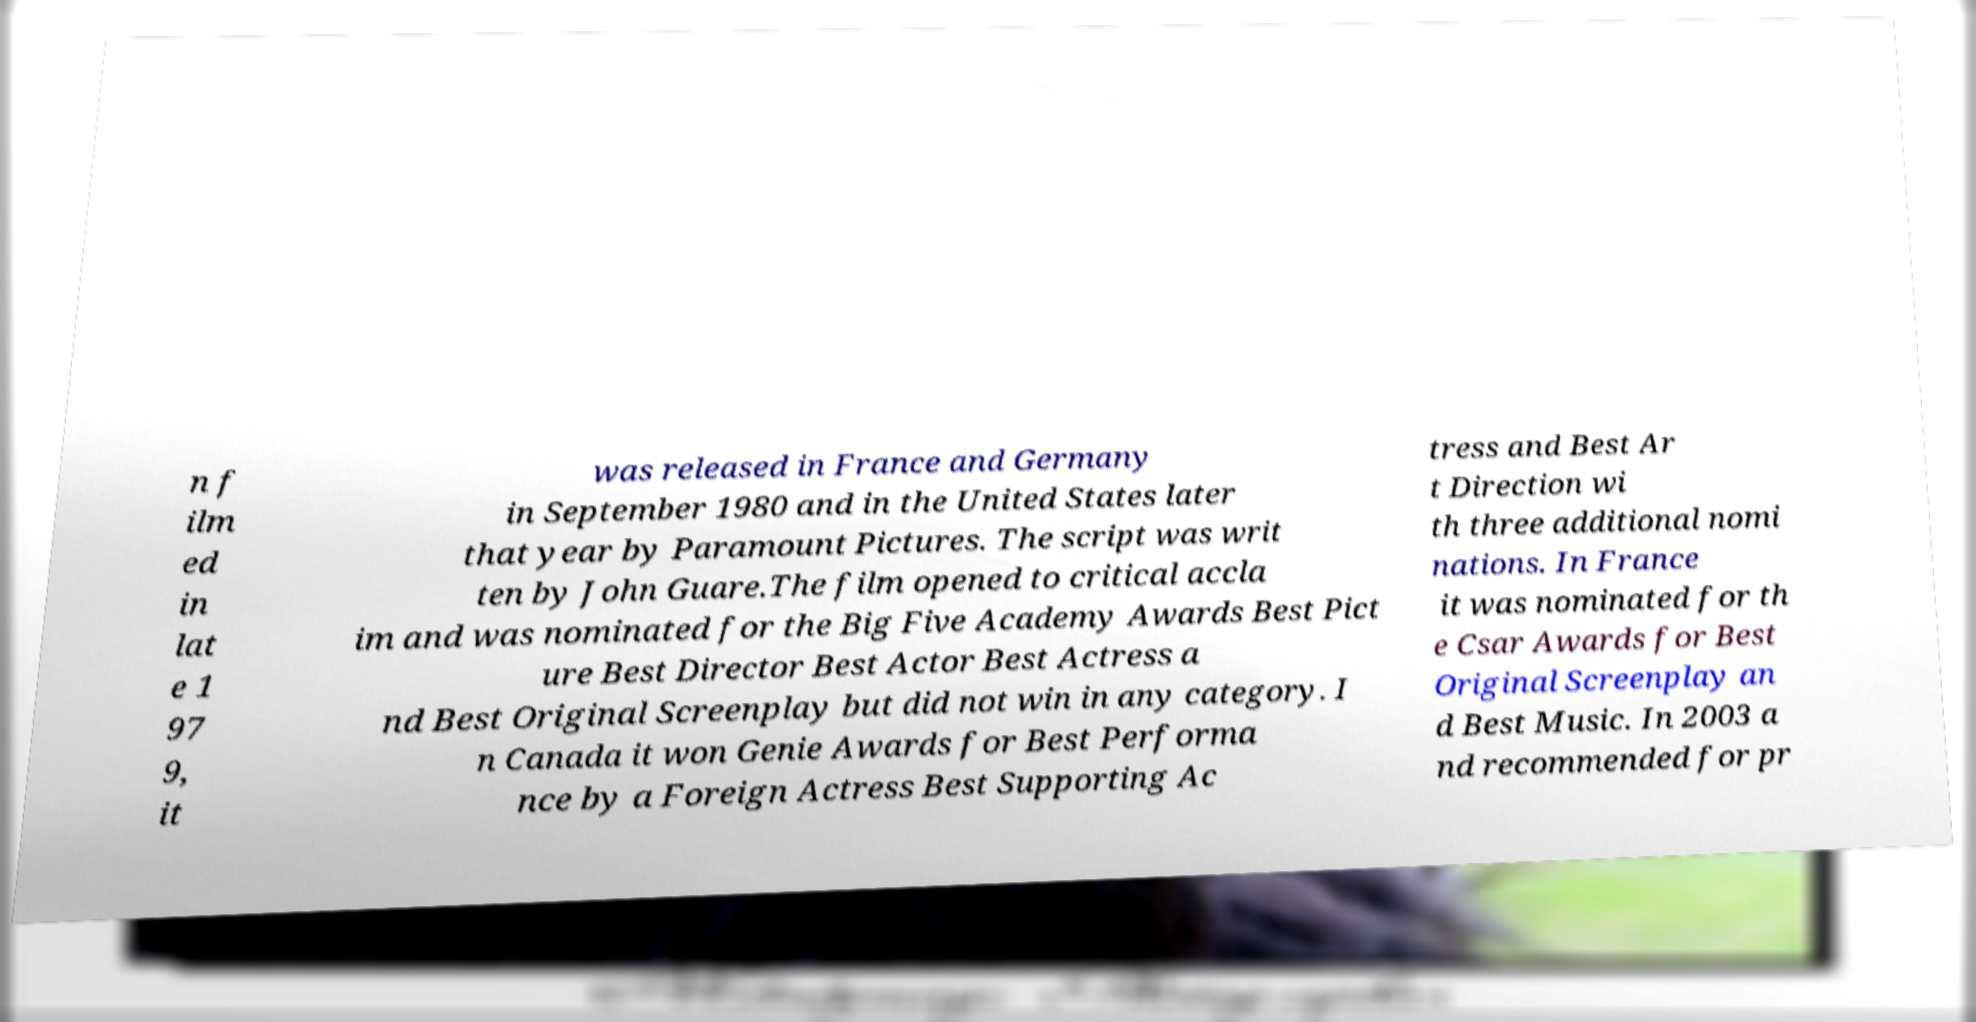There's text embedded in this image that I need extracted. Can you transcribe it verbatim? n f ilm ed in lat e 1 97 9, it was released in France and Germany in September 1980 and in the United States later that year by Paramount Pictures. The script was writ ten by John Guare.The film opened to critical accla im and was nominated for the Big Five Academy Awards Best Pict ure Best Director Best Actor Best Actress a nd Best Original Screenplay but did not win in any category. I n Canada it won Genie Awards for Best Performa nce by a Foreign Actress Best Supporting Ac tress and Best Ar t Direction wi th three additional nomi nations. In France it was nominated for th e Csar Awards for Best Original Screenplay an d Best Music. In 2003 a nd recommended for pr 